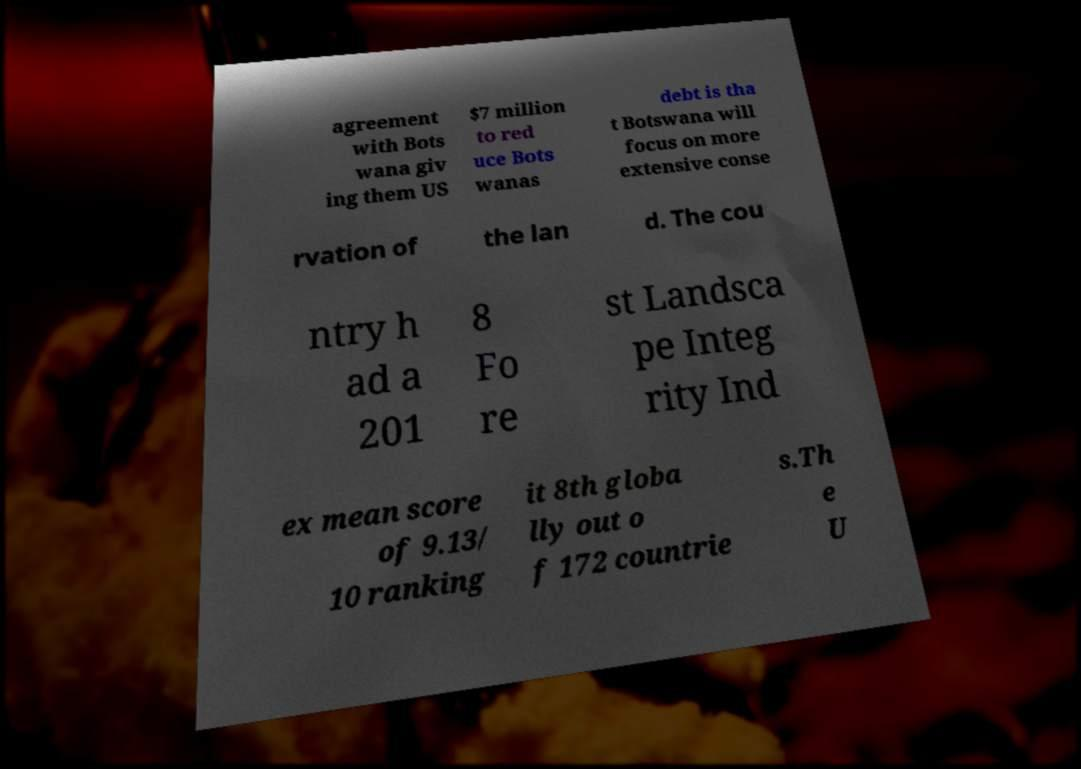For documentation purposes, I need the text within this image transcribed. Could you provide that? agreement with Bots wana giv ing them US $7 million to red uce Bots wanas debt is tha t Botswana will focus on more extensive conse rvation of the lan d. The cou ntry h ad a 201 8 Fo re st Landsca pe Integ rity Ind ex mean score of 9.13/ 10 ranking it 8th globa lly out o f 172 countrie s.Th e U 